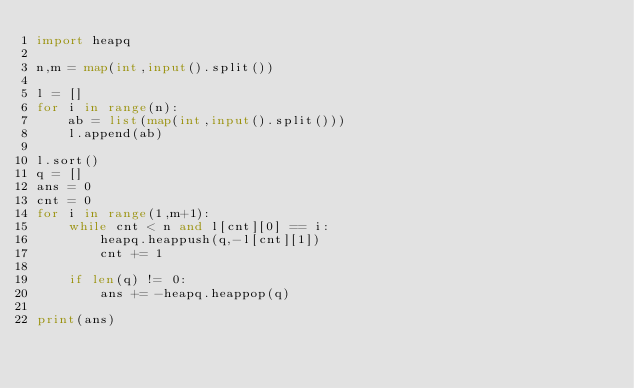Convert code to text. <code><loc_0><loc_0><loc_500><loc_500><_Python_>import heapq

n,m = map(int,input().split())

l = []
for i in range(n):
    ab = list(map(int,input().split()))
    l.append(ab)

l.sort()
q = []
ans = 0
cnt = 0
for i in range(1,m+1):
    while cnt < n and l[cnt][0] == i:
        heapq.heappush(q,-l[cnt][1])
        cnt += 1
    
    if len(q) != 0:
        ans += -heapq.heappop(q)

print(ans)</code> 